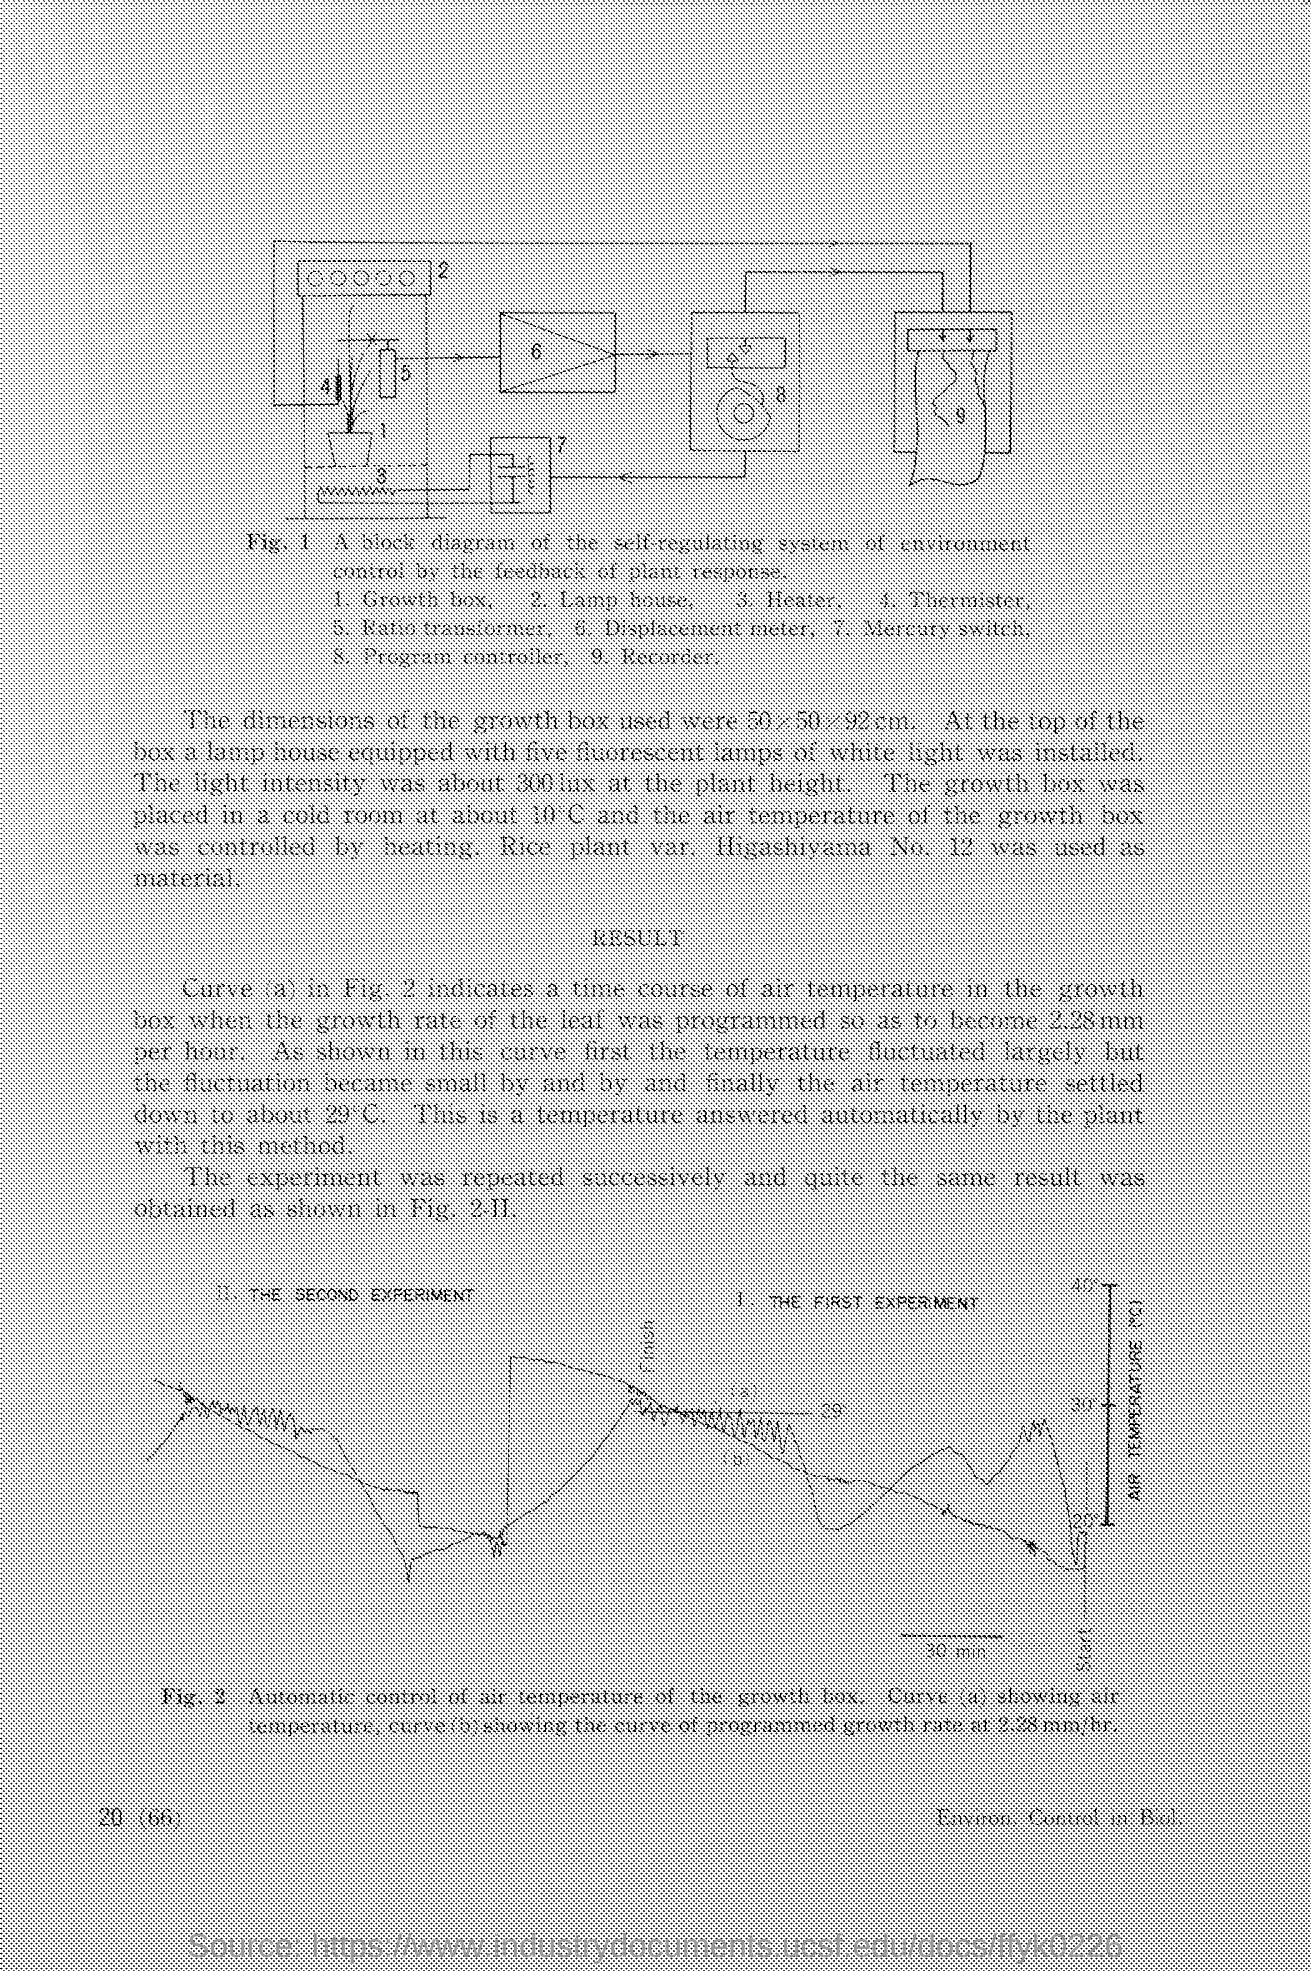How many fluorescent lamps is the lamp house equipped with?
Keep it short and to the point. Five. In which room the growth box was placed?
Provide a short and direct response. Cold room. 